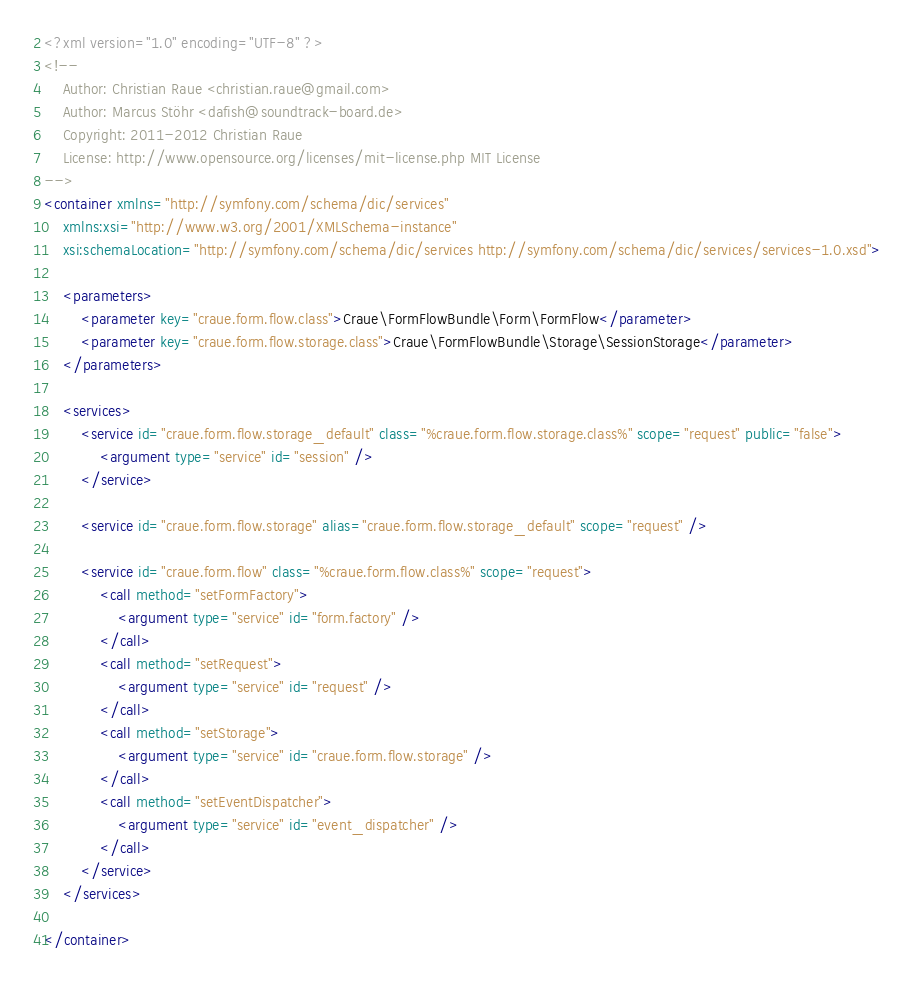<code> <loc_0><loc_0><loc_500><loc_500><_XML_><?xml version="1.0" encoding="UTF-8" ?>
<!--
	Author: Christian Raue <christian.raue@gmail.com>
	Author: Marcus Stöhr <dafish@soundtrack-board.de>
	Copyright: 2011-2012 Christian Raue
	License: http://www.opensource.org/licenses/mit-license.php MIT License
-->
<container xmlns="http://symfony.com/schema/dic/services"
	xmlns:xsi="http://www.w3.org/2001/XMLSchema-instance"
	xsi:schemaLocation="http://symfony.com/schema/dic/services http://symfony.com/schema/dic/services/services-1.0.xsd">

	<parameters>
		<parameter key="craue.form.flow.class">Craue\FormFlowBundle\Form\FormFlow</parameter>
		<parameter key="craue.form.flow.storage.class">Craue\FormFlowBundle\Storage\SessionStorage</parameter>
	</parameters>

	<services>
		<service id="craue.form.flow.storage_default" class="%craue.form.flow.storage.class%" scope="request" public="false">
			<argument type="service" id="session" />
		</service>

		<service id="craue.form.flow.storage" alias="craue.form.flow.storage_default" scope="request" />

		<service id="craue.form.flow" class="%craue.form.flow.class%" scope="request">
			<call method="setFormFactory">
				<argument type="service" id="form.factory" />
			</call>
			<call method="setRequest">
				<argument type="service" id="request" />
			</call>
			<call method="setStorage">
				<argument type="service" id="craue.form.flow.storage" />
			</call>
			<call method="setEventDispatcher">
				<argument type="service" id="event_dispatcher" />
			</call>
		</service>
	</services>

</container>
</code> 